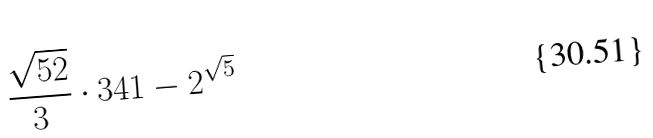Convert formula to latex. <formula><loc_0><loc_0><loc_500><loc_500>\frac { \sqrt { 5 2 } } { 3 } \cdot 3 4 1 - 2 ^ { \sqrt { 5 } }</formula> 